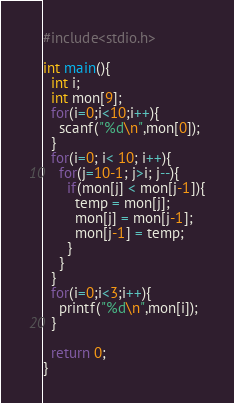Convert code to text. <code><loc_0><loc_0><loc_500><loc_500><_C_>#include<stdio.h>

int main(){
  int i;
  int mon[9];
  for(i=0;i<10;i++){
    scanf("%d\n",mon[0]);
  }
  for(i=0; i< 10; i++){
    for(j=10-1; j>i; j--){
      if(mon[j] < mon[j-1]){
        temp = mon[j];
        mon[j] = mon[j-1];
        mon[j-1] = temp;
      }
    }
  }
  for(i=0;i<3;i++){
    printf("%d\n",mon[i]);
  }

  return 0;
}</code> 